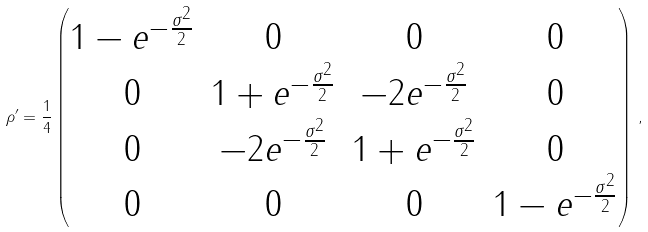<formula> <loc_0><loc_0><loc_500><loc_500>\rho ^ { \prime } = \frac { 1 } { 4 } \begin{pmatrix} 1 - e ^ { - \frac { \sigma ^ { 2 } } { 2 } } & 0 & 0 & 0 \\ 0 & 1 + e ^ { - \frac { \sigma ^ { 2 } } { 2 } } & - 2 e ^ { - \frac { \sigma ^ { 2 } } { 2 } } & 0 \\ 0 & - 2 e ^ { - \frac { \sigma ^ { 2 } } { 2 } } & 1 + e ^ { - \frac { \sigma ^ { 2 } } { 2 } } & 0 \\ 0 & 0 & 0 & 1 - e ^ { - \frac { \sigma ^ { 2 } } { 2 } } \\ \end{pmatrix} \, ,</formula> 